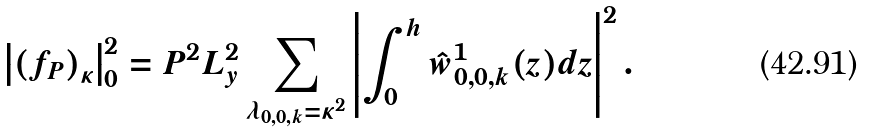<formula> <loc_0><loc_0><loc_500><loc_500>\left | \left ( f _ { P } \right ) _ { \kappa } \right | _ { 0 } ^ { 2 } = P ^ { 2 } L _ { y } ^ { 2 } \sum _ { \lambda _ { 0 , 0 , k } = \kappa ^ { 2 } } \left | \int _ { 0 } ^ { h } \hat { w } ^ { 1 } _ { 0 , 0 , k } ( z ) d z \right | ^ { 2 } .</formula> 